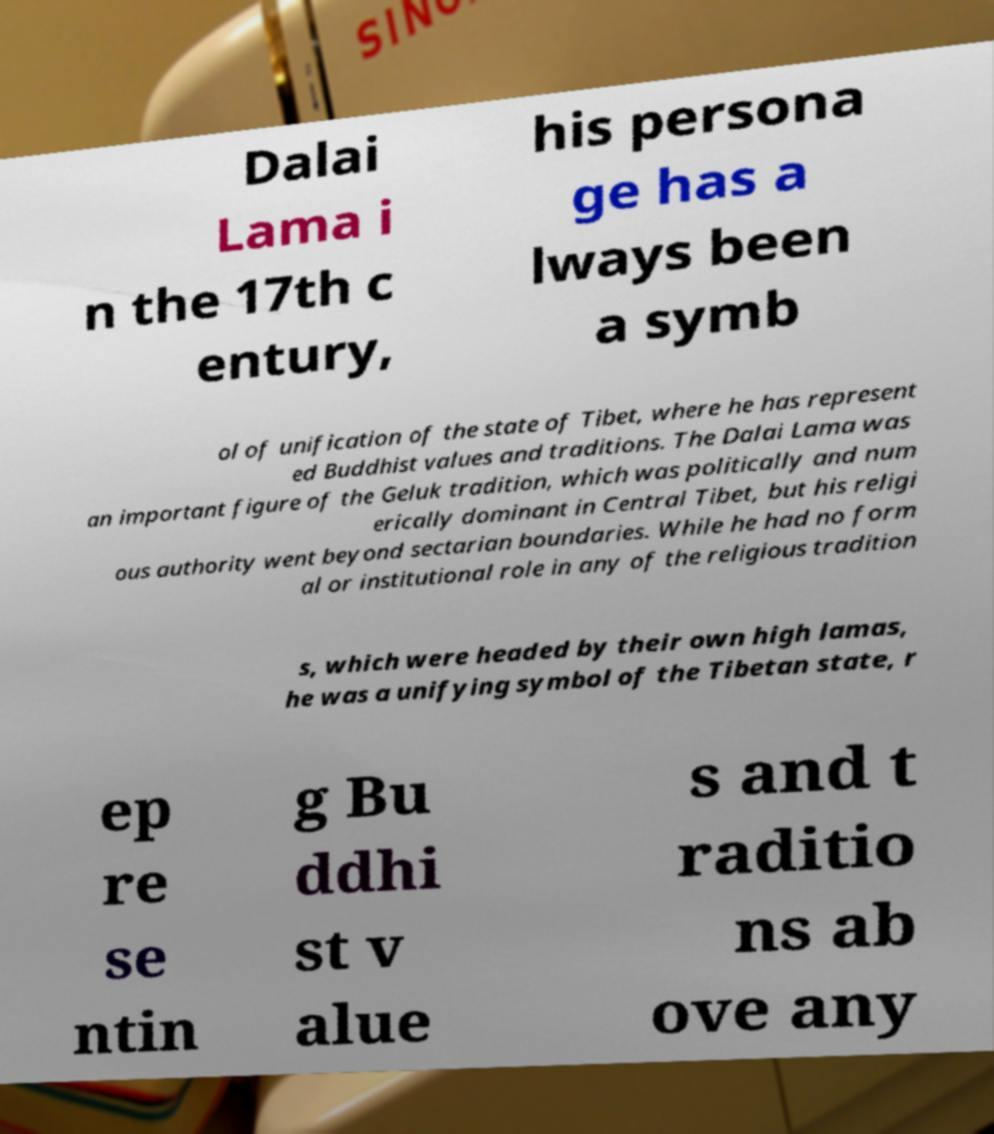Could you extract and type out the text from this image? Dalai Lama i n the 17th c entury, his persona ge has a lways been a symb ol of unification of the state of Tibet, where he has represent ed Buddhist values and traditions. The Dalai Lama was an important figure of the Geluk tradition, which was politically and num erically dominant in Central Tibet, but his religi ous authority went beyond sectarian boundaries. While he had no form al or institutional role in any of the religious tradition s, which were headed by their own high lamas, he was a unifying symbol of the Tibetan state, r ep re se ntin g Bu ddhi st v alue s and t raditio ns ab ove any 